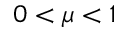<formula> <loc_0><loc_0><loc_500><loc_500>0 < \mu < 1</formula> 